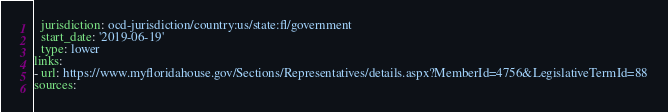Convert code to text. <code><loc_0><loc_0><loc_500><loc_500><_YAML_>  jurisdiction: ocd-jurisdiction/country:us/state:fl/government
  start_date: '2019-06-19'
  type: lower
links:
- url: https://www.myfloridahouse.gov/Sections/Representatives/details.aspx?MemberId=4756&LegislativeTermId=88
sources:</code> 